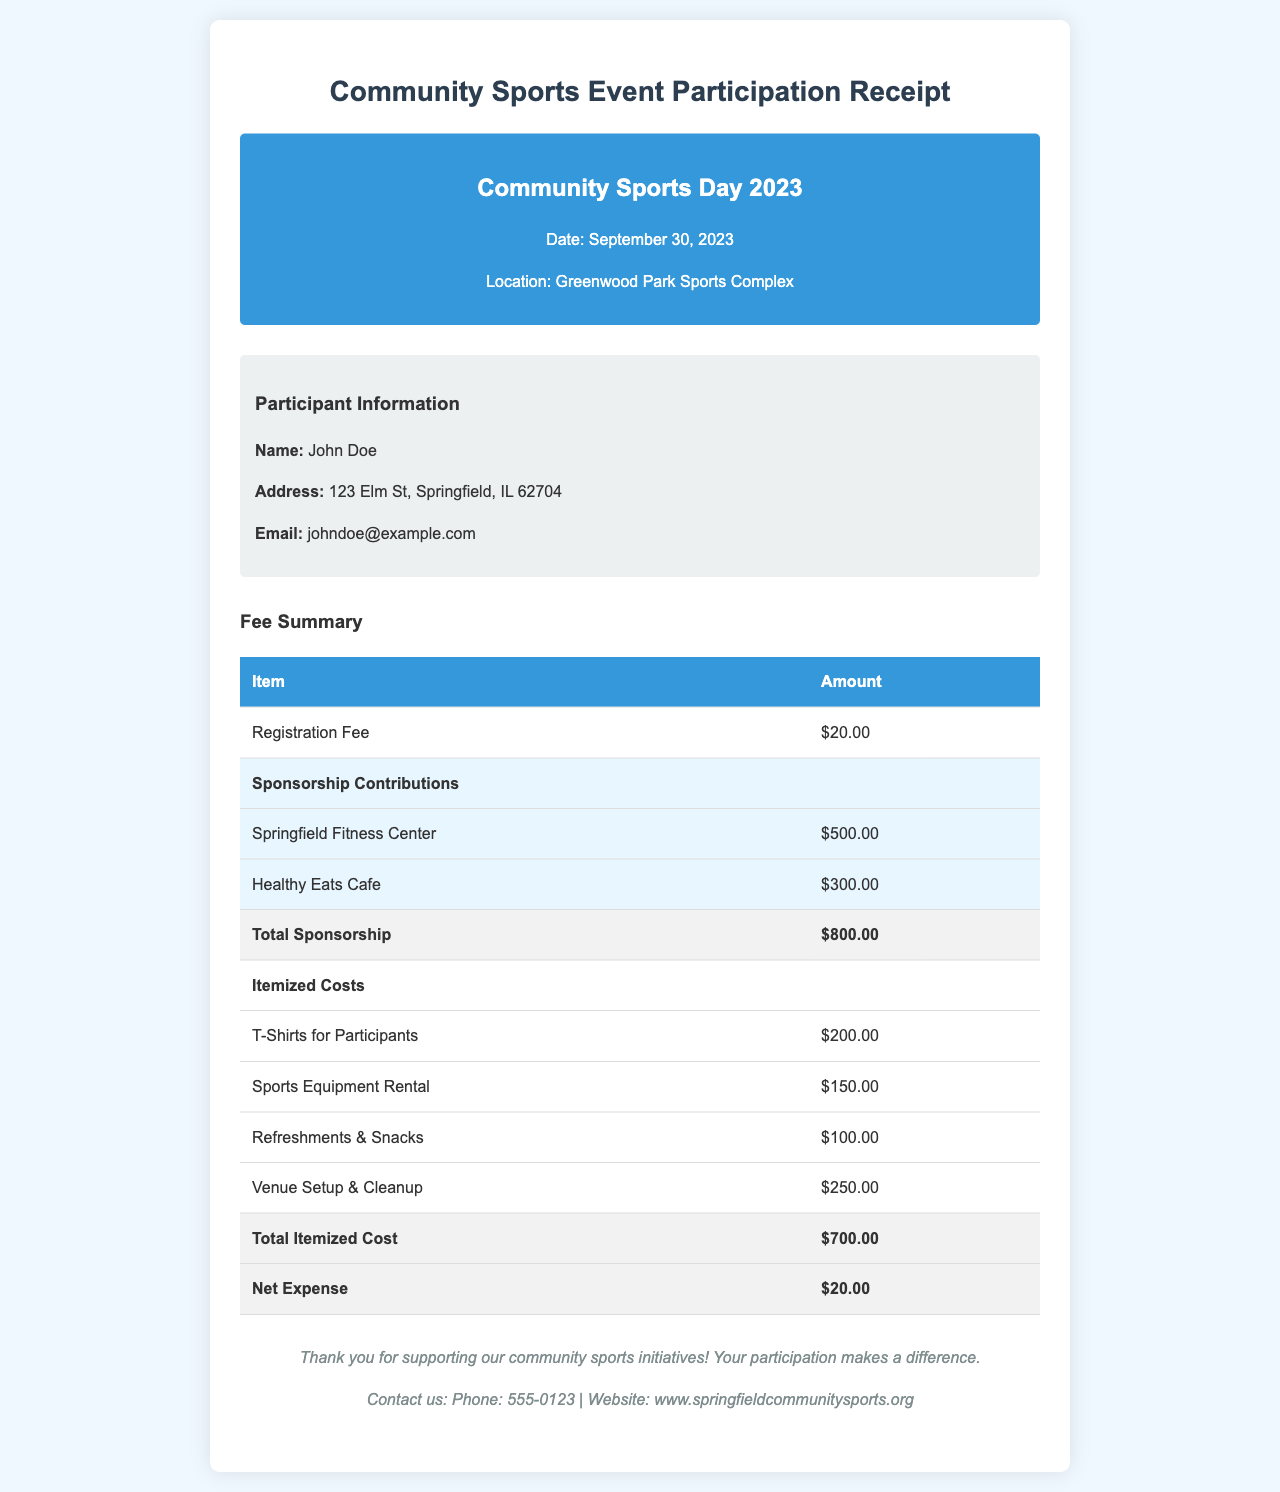What is the date of the event? The date of the event is explicitly mentioned in the document as September 30, 2023.
Answer: September 30, 2023 Who is the participant? The participant's name is provided in the participant information section of the document as John Doe.
Answer: John Doe What is the registration fee? The registration fee is specified in the fee summary section as $20.00.
Answer: $20.00 What is the total sponsorship amount? The total sponsorship amount is calculated by summing Springfield Fitness Center and Healthy Eats Cafe contributions, which totals $800.00.
Answer: $800.00 What is the total itemized cost? The total itemized cost is given in the table and sums up to $700.00.
Answer: $700.00 What is the net expense? The net expense is presented in the document and is calculated to be $20.00.
Answer: $20.00 What venue hosted the event? The location of the event is indicated as Greenwood Park Sports Complex in the document.
Answer: Greenwood Park Sports Complex What was one of the itemized costs for refreshments? One of the itemized costs specifically for refreshments is mentioned as $100.00 in the costs section.
Answer: $100.00 